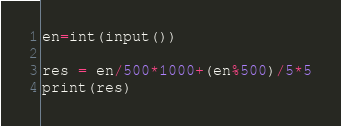Convert code to text. <code><loc_0><loc_0><loc_500><loc_500><_Python_>en=int(input())

res = en/500*1000+(en%500)/5*5
print(res)</code> 